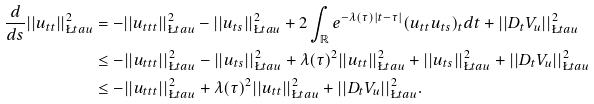Convert formula to latex. <formula><loc_0><loc_0><loc_500><loc_500>\frac { d } { d s } | | u _ { t t } | | ^ { 2 } _ { \L t a u } & = - | | u _ { t t t } | | ^ { 2 } _ { \L t a u } - | | u _ { t s } | | ^ { 2 } _ { \L t a u } + 2 \int _ { \mathbb { R } } e ^ { - \lambda ( \tau ) | t - \tau | } ( u _ { t t } u _ { t s } ) _ { t } d t + | | D _ { t } V _ { u } | | ^ { 2 } _ { \L t a u } \\ & \leq - | | u _ { t t t } | | ^ { 2 } _ { \L t a u } - | | u _ { t s } | | ^ { 2 } _ { \L t a u } + \lambda ( \tau ) ^ { 2 } | | u _ { t t } | | ^ { 2 } _ { \L t a u } + | | u _ { t s } | | ^ { 2 } _ { \L t a u } + | | D _ { t } V _ { u } | | ^ { 2 } _ { \L t a u } \\ & \leq - | | u _ { t t t } | | ^ { 2 } _ { \L t a u } + \lambda ( \tau ) ^ { 2 } | | u _ { t t } | | ^ { 2 } _ { \L t a u } + | | D _ { t } V _ { u } | | ^ { 2 } _ { \L t a u } .</formula> 